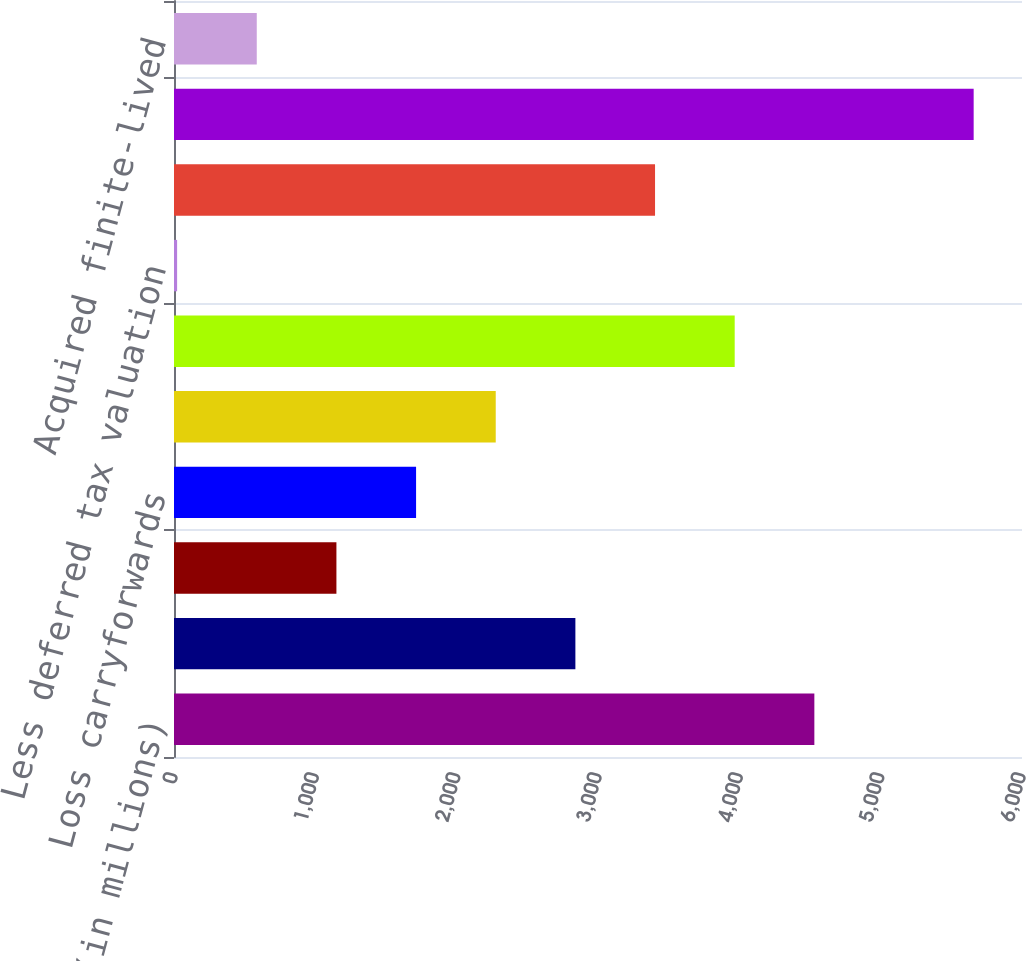Convert chart to OTSL. <chart><loc_0><loc_0><loc_500><loc_500><bar_chart><fcel>(in millions)<fcel>Compensation and benefits<fcel>Unrealized investment losses<fcel>Loss carryforwards<fcel>Other<fcel>Gross deferred tax assets<fcel>Less deferred tax valuation<fcel>Deferred tax assets net of<fcel>Goodwill and acquired<fcel>Acquired finite-lived<nl><fcel>4530.8<fcel>2840<fcel>1149.2<fcel>1712.8<fcel>2276.4<fcel>3967.2<fcel>22<fcel>3403.6<fcel>5658<fcel>585.6<nl></chart> 